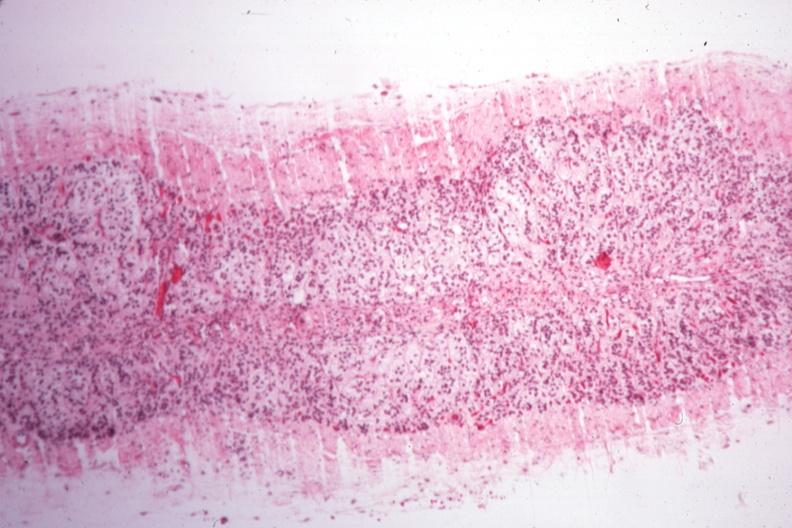does this image show rather good example of atrophy case of type i diabetes with pituitectomy for nine years for retinal lesions?
Answer the question using a single word or phrase. Yes 